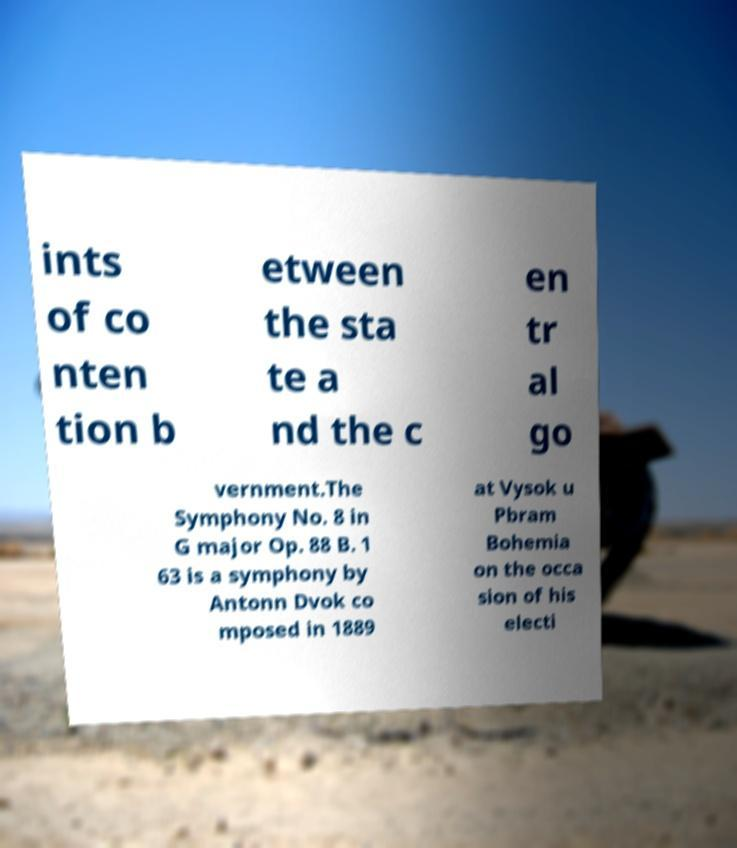Could you extract and type out the text from this image? ints of co nten tion b etween the sta te a nd the c en tr al go vernment.The Symphony No. 8 in G major Op. 88 B. 1 63 is a symphony by Antonn Dvok co mposed in 1889 at Vysok u Pbram Bohemia on the occa sion of his electi 